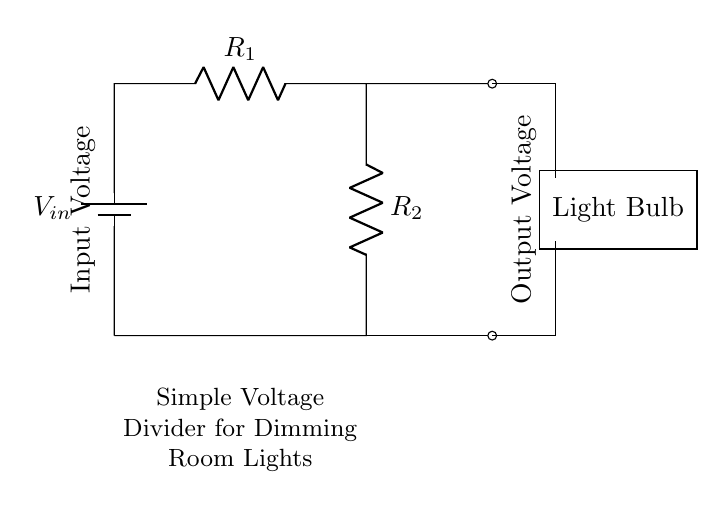What are the components in this circuit? The components in the circuit include a battery, two resistors (R1 and R2), and a light bulb. These are visually identifiable, with the battery at the left, two resistors arranged vertically, and the light bulb indicated to the right of the circuit.
Answer: battery, two resistors, light bulb What is the role of R1 and R2 in the circuit? R1 and R2 form a voltage divider that determines the output voltage across the light bulb. The voltage drop across these resistors is what allows for dimming, as they share the input voltage based on their resistance values.
Answer: voltage divider What is the output voltage in relation to the input voltage? The output voltage is the reduced voltage across the light bulb, which is dependent on the resistances of R1 and R2 and the input voltage. Using the voltage divider formula (Vout = Vin * R2 / (R1 + R2)), you can calculate it.
Answer: reduced voltage How can the brightness of the light bulb be controlled? The brightness can be controlled by adjusting the values of R1 and R2, which in turn alters the output voltage reaching the light bulb. By changing the ratio of these resistors, the current through the bulb varies, affecting its brightness.
Answer: by adjusting R1 and R2 What happens if R2 is increased? If R2 is increased, the output voltage across the light bulb increases, which makes the bulb brighter. This occurs because a larger resistance in the voltage divider leads to a higher voltage drop across R2 according to the voltage divider principle.
Answer: bulb gets brighter 